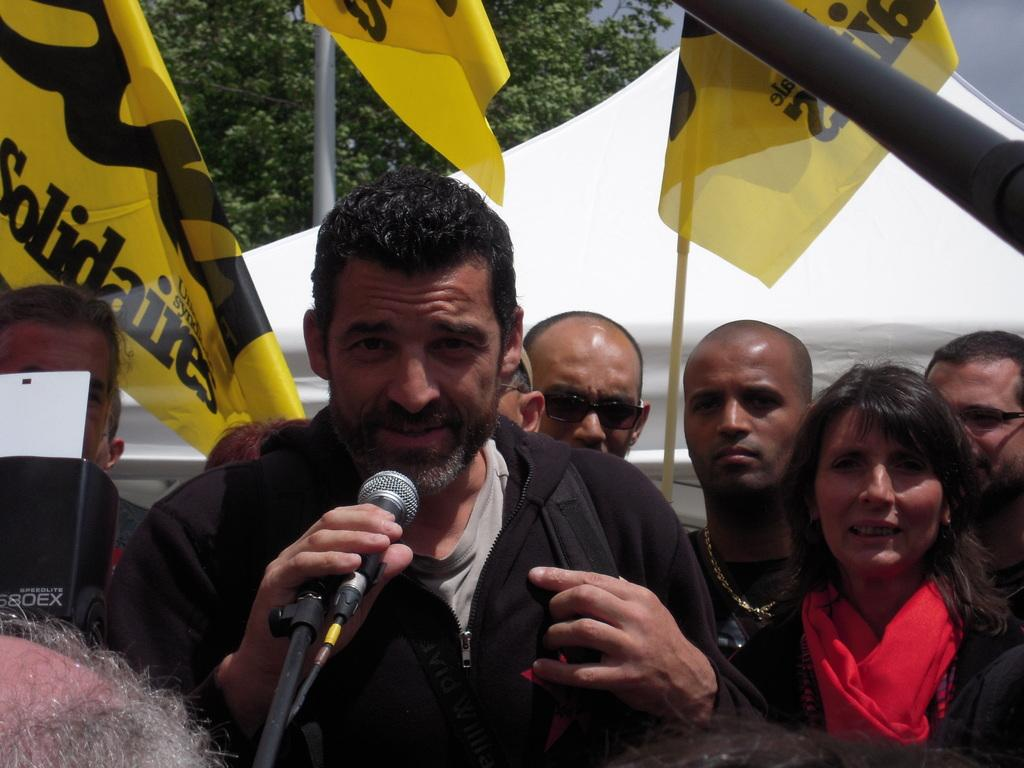How many people are in the image? There is a group of people in the image. What is one man in the group doing? One man in the group is holding a microphone. What type of toothbrush is being used by the man holding the microphone in the image? There is no toothbrush present in the image; the man is holding a microphone. 